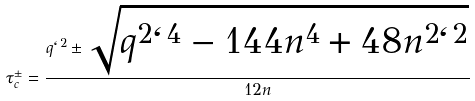Convert formula to latex. <formula><loc_0><loc_0><loc_500><loc_500>\tau _ { c } ^ { \pm } = \frac { q \ell ^ { 2 } \pm \sqrt { q ^ { 2 } \ell ^ { 4 } - 1 4 4 n ^ { 4 } + 4 8 n ^ { 2 } \ell ^ { 2 } } } { 1 2 n }</formula> 